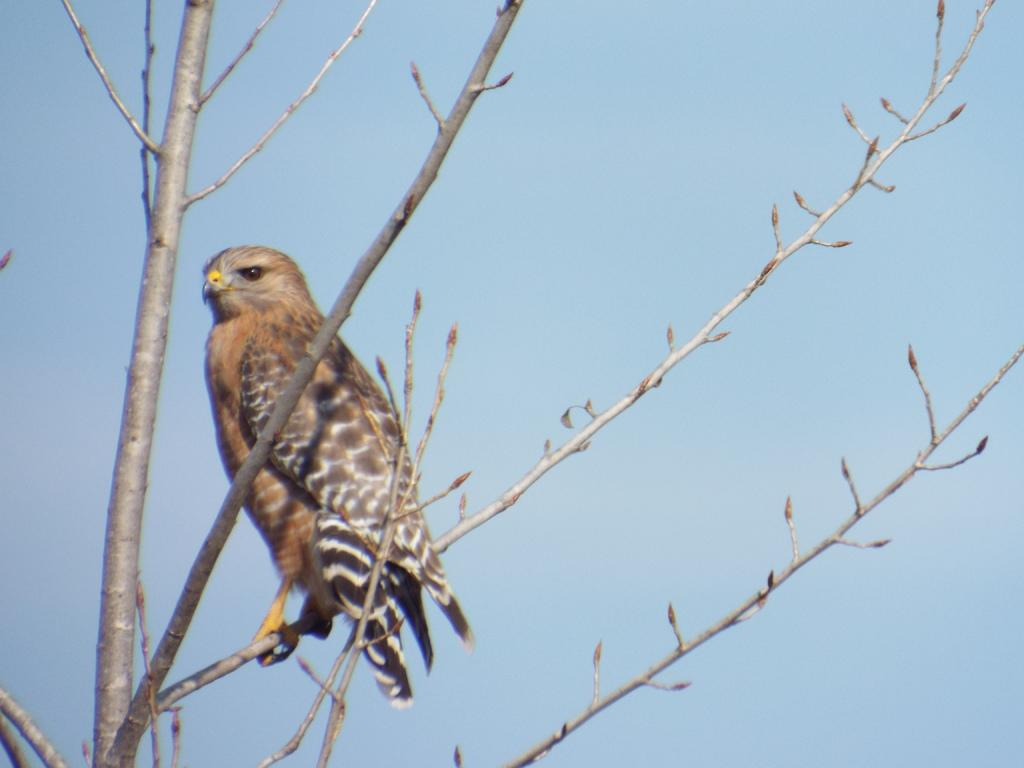What type of animal can be seen in the picture? There is a bird in the picture. Where is the bird located in the image? The bird is sitting on a branch of a tree. What physical features does the bird have? The bird has feathers and a beak. What is the condition of the sky in the picture? The sky is clear in the picture. What color is the unit that the bird is using to communicate in the image? There is no unit present in the image, and the bird is not using any device to communicate. 